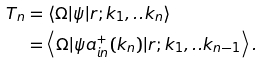Convert formula to latex. <formula><loc_0><loc_0><loc_500><loc_500>T _ { n } & = \left \langle \Omega | \psi | r ; k _ { 1 } , . . k _ { n } \right \rangle \\ & = \left \langle \Omega | \psi a _ { i n } ^ { + } ( k _ { n } ) | r ; k _ { 1 } , . . k _ { n - 1 } \right \rangle .</formula> 